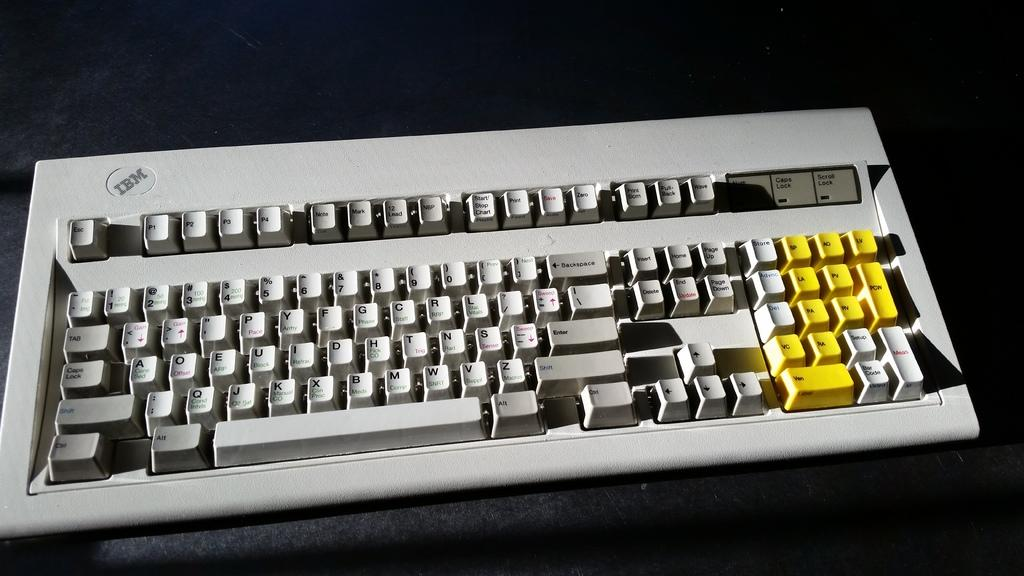<image>
Present a compact description of the photo's key features. One of the first keyboards made by IBM. 